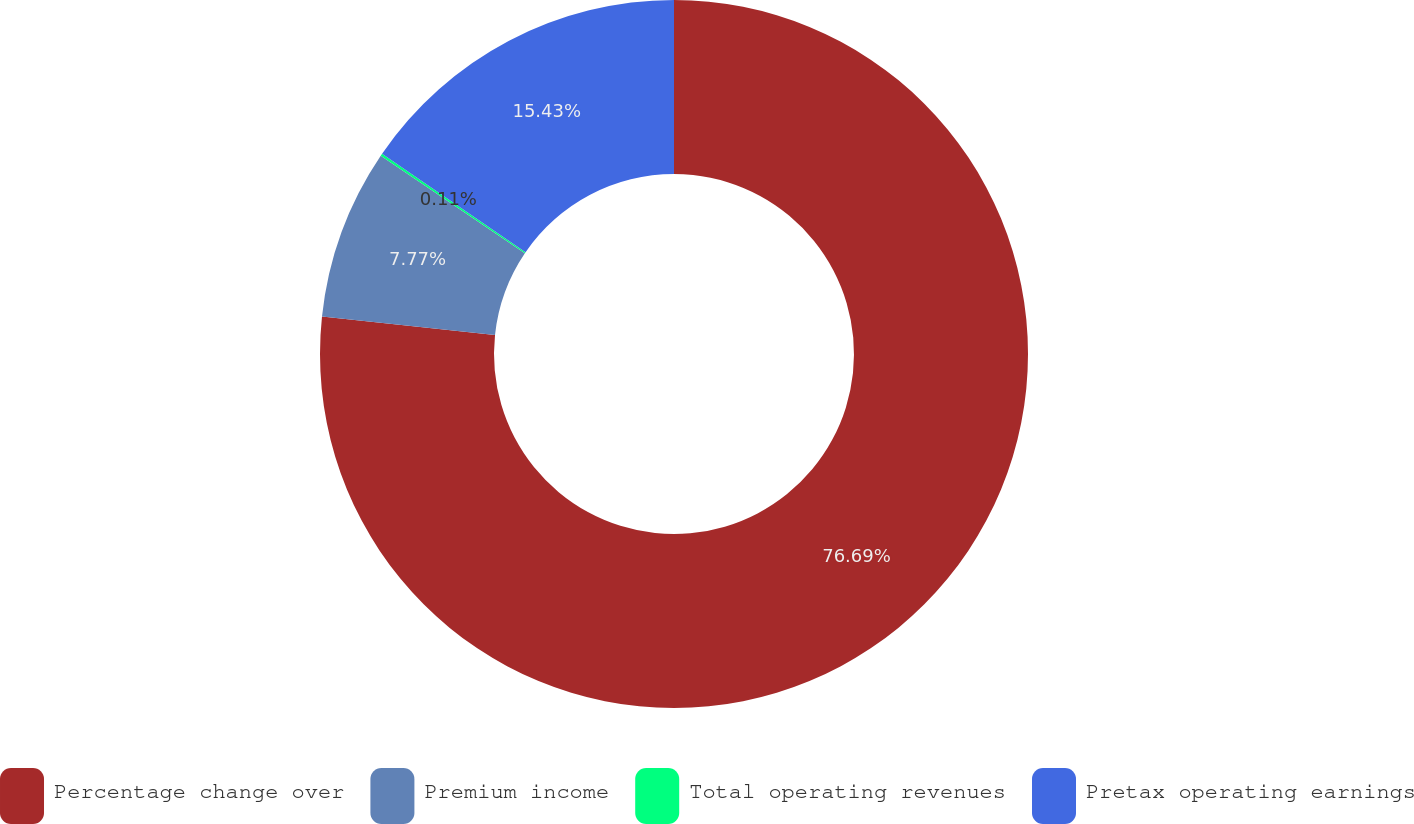Convert chart to OTSL. <chart><loc_0><loc_0><loc_500><loc_500><pie_chart><fcel>Percentage change over<fcel>Premium income<fcel>Total operating revenues<fcel>Pretax operating earnings<nl><fcel>76.69%<fcel>7.77%<fcel>0.11%<fcel>15.43%<nl></chart> 